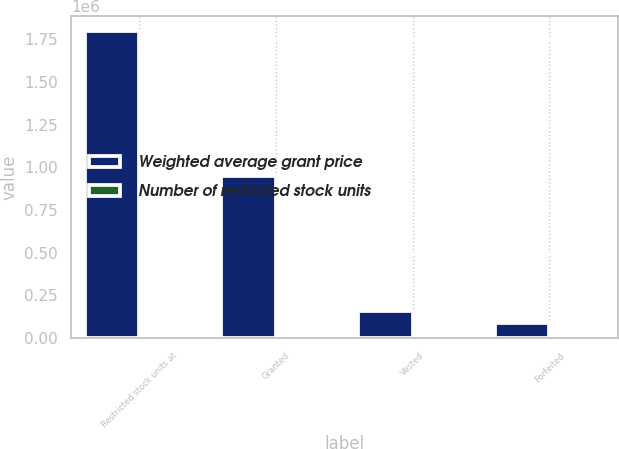<chart> <loc_0><loc_0><loc_500><loc_500><stacked_bar_chart><ecel><fcel>Restricted stock units at<fcel>Granted<fcel>Vested<fcel>Forfeited<nl><fcel>Weighted average grant price<fcel>1.79854e+06<fcel>949418<fcel>160580<fcel>89553<nl><fcel>Number of restricted stock units<fcel>27.39<fcel>25.99<fcel>20.17<fcel>20.13<nl></chart> 